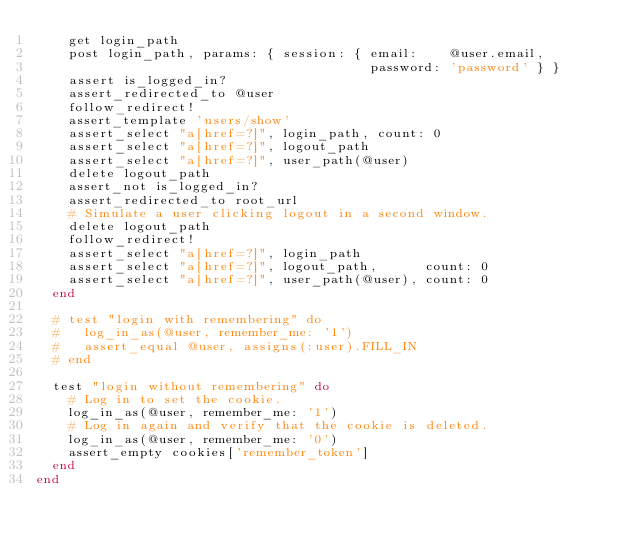<code> <loc_0><loc_0><loc_500><loc_500><_Ruby_>    get login_path
    post login_path, params: { session: { email:    @user.email,
                                          password: 'password' } }
    assert is_logged_in?
    assert_redirected_to @user
    follow_redirect!
    assert_template 'users/show'
    assert_select "a[href=?]", login_path, count: 0
    assert_select "a[href=?]", logout_path
    assert_select "a[href=?]", user_path(@user)
    delete logout_path
    assert_not is_logged_in?
    assert_redirected_to root_url
    # Simulate a user clicking logout in a second window.
    delete logout_path
    follow_redirect!
    assert_select "a[href=?]", login_path
    assert_select "a[href=?]", logout_path,      count: 0
    assert_select "a[href=?]", user_path(@user), count: 0
  end

  # test "login with remembering" do
  #   log_in_as(@user, remember_me: '1')
  #   assert_equal @user, assigns(:user).FILL_IN
  # end

  test "login without remembering" do
    # Log in to set the cookie.
    log_in_as(@user, remember_me: '1')
    # Log in again and verify that the cookie is deleted.
    log_in_as(@user, remember_me: '0')
    assert_empty cookies['remember_token']
  end
end</code> 